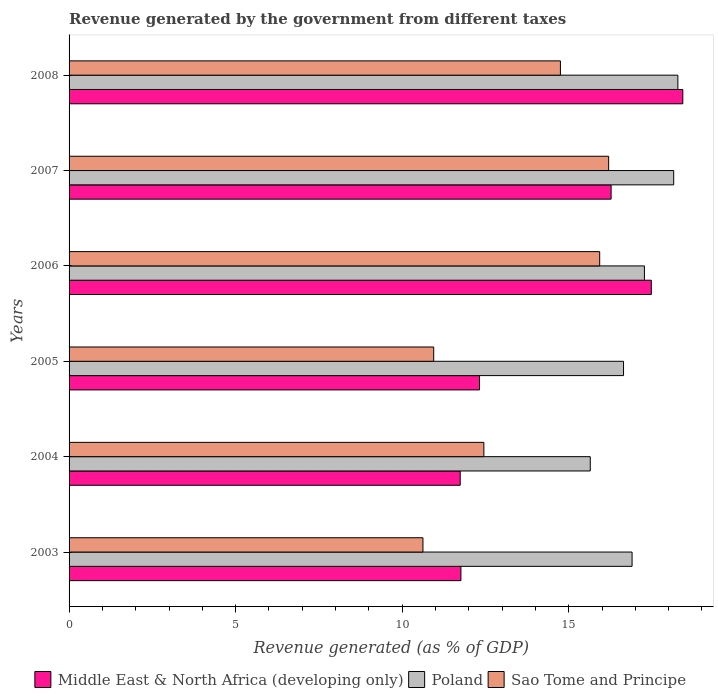How many different coloured bars are there?
Your answer should be compact. 3. How many bars are there on the 2nd tick from the bottom?
Your answer should be compact. 3. What is the revenue generated by the government in Middle East & North Africa (developing only) in 2007?
Offer a terse response. 16.27. Across all years, what is the maximum revenue generated by the government in Poland?
Provide a short and direct response. 18.28. Across all years, what is the minimum revenue generated by the government in Middle East & North Africa (developing only)?
Give a very brief answer. 11.74. In which year was the revenue generated by the government in Poland maximum?
Your response must be concise. 2008. What is the total revenue generated by the government in Sao Tome and Principe in the graph?
Give a very brief answer. 80.91. What is the difference between the revenue generated by the government in Poland in 2007 and that in 2008?
Provide a short and direct response. -0.13. What is the difference between the revenue generated by the government in Middle East & North Africa (developing only) in 2005 and the revenue generated by the government in Sao Tome and Principe in 2008?
Your response must be concise. -2.43. What is the average revenue generated by the government in Middle East & North Africa (developing only) per year?
Your answer should be compact. 14.67. In the year 2006, what is the difference between the revenue generated by the government in Sao Tome and Principe and revenue generated by the government in Poland?
Make the answer very short. -1.34. In how many years, is the revenue generated by the government in Sao Tome and Principe greater than 13 %?
Make the answer very short. 3. What is the ratio of the revenue generated by the government in Poland in 2005 to that in 2008?
Give a very brief answer. 0.91. Is the revenue generated by the government in Poland in 2003 less than that in 2008?
Keep it short and to the point. Yes. What is the difference between the highest and the second highest revenue generated by the government in Middle East & North Africa (developing only)?
Keep it short and to the point. 0.95. What is the difference between the highest and the lowest revenue generated by the government in Sao Tome and Principe?
Your response must be concise. 5.57. Is the sum of the revenue generated by the government in Poland in 2006 and 2007 greater than the maximum revenue generated by the government in Sao Tome and Principe across all years?
Ensure brevity in your answer.  Yes. What does the 1st bar from the top in 2005 represents?
Your answer should be very brief. Sao Tome and Principe. What does the 1st bar from the bottom in 2008 represents?
Provide a succinct answer. Middle East & North Africa (developing only). Is it the case that in every year, the sum of the revenue generated by the government in Sao Tome and Principe and revenue generated by the government in Poland is greater than the revenue generated by the government in Middle East & North Africa (developing only)?
Your answer should be very brief. Yes. How many bars are there?
Ensure brevity in your answer.  18. Are all the bars in the graph horizontal?
Your response must be concise. Yes. How many years are there in the graph?
Make the answer very short. 6. What is the difference between two consecutive major ticks on the X-axis?
Provide a short and direct response. 5. Are the values on the major ticks of X-axis written in scientific E-notation?
Keep it short and to the point. No. Does the graph contain grids?
Provide a succinct answer. No. How many legend labels are there?
Provide a succinct answer. 3. What is the title of the graph?
Give a very brief answer. Revenue generated by the government from different taxes. Does "Zimbabwe" appear as one of the legend labels in the graph?
Give a very brief answer. No. What is the label or title of the X-axis?
Make the answer very short. Revenue generated (as % of GDP). What is the Revenue generated (as % of GDP) in Middle East & North Africa (developing only) in 2003?
Make the answer very short. 11.76. What is the Revenue generated (as % of GDP) in Poland in 2003?
Keep it short and to the point. 16.9. What is the Revenue generated (as % of GDP) of Sao Tome and Principe in 2003?
Provide a short and direct response. 10.62. What is the Revenue generated (as % of GDP) in Middle East & North Africa (developing only) in 2004?
Offer a very short reply. 11.74. What is the Revenue generated (as % of GDP) in Poland in 2004?
Your answer should be very brief. 15.65. What is the Revenue generated (as % of GDP) in Sao Tome and Principe in 2004?
Your response must be concise. 12.45. What is the Revenue generated (as % of GDP) in Middle East & North Africa (developing only) in 2005?
Your answer should be compact. 12.32. What is the Revenue generated (as % of GDP) in Poland in 2005?
Provide a short and direct response. 16.65. What is the Revenue generated (as % of GDP) in Sao Tome and Principe in 2005?
Offer a terse response. 10.95. What is the Revenue generated (as % of GDP) in Middle East & North Africa (developing only) in 2006?
Make the answer very short. 17.48. What is the Revenue generated (as % of GDP) in Poland in 2006?
Provide a succinct answer. 17.27. What is the Revenue generated (as % of GDP) in Sao Tome and Principe in 2006?
Ensure brevity in your answer.  15.93. What is the Revenue generated (as % of GDP) of Middle East & North Africa (developing only) in 2007?
Your answer should be very brief. 16.27. What is the Revenue generated (as % of GDP) of Poland in 2007?
Offer a very short reply. 18.15. What is the Revenue generated (as % of GDP) in Sao Tome and Principe in 2007?
Make the answer very short. 16.2. What is the Revenue generated (as % of GDP) of Middle East & North Africa (developing only) in 2008?
Ensure brevity in your answer.  18.43. What is the Revenue generated (as % of GDP) of Poland in 2008?
Your answer should be very brief. 18.28. What is the Revenue generated (as % of GDP) in Sao Tome and Principe in 2008?
Give a very brief answer. 14.75. Across all years, what is the maximum Revenue generated (as % of GDP) of Middle East & North Africa (developing only)?
Give a very brief answer. 18.43. Across all years, what is the maximum Revenue generated (as % of GDP) in Poland?
Keep it short and to the point. 18.28. Across all years, what is the maximum Revenue generated (as % of GDP) of Sao Tome and Principe?
Give a very brief answer. 16.2. Across all years, what is the minimum Revenue generated (as % of GDP) of Middle East & North Africa (developing only)?
Provide a succinct answer. 11.74. Across all years, what is the minimum Revenue generated (as % of GDP) in Poland?
Make the answer very short. 15.65. Across all years, what is the minimum Revenue generated (as % of GDP) in Sao Tome and Principe?
Offer a very short reply. 10.62. What is the total Revenue generated (as % of GDP) of Middle East & North Africa (developing only) in the graph?
Provide a short and direct response. 88.01. What is the total Revenue generated (as % of GDP) in Poland in the graph?
Offer a very short reply. 102.9. What is the total Revenue generated (as % of GDP) of Sao Tome and Principe in the graph?
Give a very brief answer. 80.91. What is the difference between the Revenue generated (as % of GDP) in Middle East & North Africa (developing only) in 2003 and that in 2004?
Keep it short and to the point. 0.02. What is the difference between the Revenue generated (as % of GDP) in Poland in 2003 and that in 2004?
Your response must be concise. 1.26. What is the difference between the Revenue generated (as % of GDP) of Sao Tome and Principe in 2003 and that in 2004?
Ensure brevity in your answer.  -1.83. What is the difference between the Revenue generated (as % of GDP) in Middle East & North Africa (developing only) in 2003 and that in 2005?
Provide a succinct answer. -0.56. What is the difference between the Revenue generated (as % of GDP) in Poland in 2003 and that in 2005?
Your response must be concise. 0.26. What is the difference between the Revenue generated (as % of GDP) in Sao Tome and Principe in 2003 and that in 2005?
Offer a very short reply. -0.32. What is the difference between the Revenue generated (as % of GDP) in Middle East & North Africa (developing only) in 2003 and that in 2006?
Provide a succinct answer. -5.72. What is the difference between the Revenue generated (as % of GDP) in Poland in 2003 and that in 2006?
Give a very brief answer. -0.37. What is the difference between the Revenue generated (as % of GDP) in Sao Tome and Principe in 2003 and that in 2006?
Your answer should be very brief. -5.31. What is the difference between the Revenue generated (as % of GDP) of Middle East & North Africa (developing only) in 2003 and that in 2007?
Keep it short and to the point. -4.51. What is the difference between the Revenue generated (as % of GDP) in Poland in 2003 and that in 2007?
Offer a very short reply. -1.25. What is the difference between the Revenue generated (as % of GDP) of Sao Tome and Principe in 2003 and that in 2007?
Offer a very short reply. -5.57. What is the difference between the Revenue generated (as % of GDP) in Middle East & North Africa (developing only) in 2003 and that in 2008?
Provide a succinct answer. -6.66. What is the difference between the Revenue generated (as % of GDP) of Poland in 2003 and that in 2008?
Offer a terse response. -1.38. What is the difference between the Revenue generated (as % of GDP) in Sao Tome and Principe in 2003 and that in 2008?
Ensure brevity in your answer.  -4.13. What is the difference between the Revenue generated (as % of GDP) of Middle East & North Africa (developing only) in 2004 and that in 2005?
Provide a succinct answer. -0.58. What is the difference between the Revenue generated (as % of GDP) of Poland in 2004 and that in 2005?
Your response must be concise. -1. What is the difference between the Revenue generated (as % of GDP) in Sao Tome and Principe in 2004 and that in 2005?
Make the answer very short. 1.51. What is the difference between the Revenue generated (as % of GDP) in Middle East & North Africa (developing only) in 2004 and that in 2006?
Make the answer very short. -5.74. What is the difference between the Revenue generated (as % of GDP) of Poland in 2004 and that in 2006?
Provide a short and direct response. -1.63. What is the difference between the Revenue generated (as % of GDP) of Sao Tome and Principe in 2004 and that in 2006?
Provide a succinct answer. -3.48. What is the difference between the Revenue generated (as % of GDP) of Middle East & North Africa (developing only) in 2004 and that in 2007?
Give a very brief answer. -4.53. What is the difference between the Revenue generated (as % of GDP) in Poland in 2004 and that in 2007?
Your answer should be very brief. -2.51. What is the difference between the Revenue generated (as % of GDP) of Sao Tome and Principe in 2004 and that in 2007?
Your answer should be compact. -3.75. What is the difference between the Revenue generated (as % of GDP) in Middle East & North Africa (developing only) in 2004 and that in 2008?
Make the answer very short. -6.68. What is the difference between the Revenue generated (as % of GDP) of Poland in 2004 and that in 2008?
Your answer should be compact. -2.63. What is the difference between the Revenue generated (as % of GDP) of Sao Tome and Principe in 2004 and that in 2008?
Offer a very short reply. -2.3. What is the difference between the Revenue generated (as % of GDP) of Middle East & North Africa (developing only) in 2005 and that in 2006?
Make the answer very short. -5.16. What is the difference between the Revenue generated (as % of GDP) of Poland in 2005 and that in 2006?
Give a very brief answer. -0.63. What is the difference between the Revenue generated (as % of GDP) in Sao Tome and Principe in 2005 and that in 2006?
Offer a very short reply. -4.98. What is the difference between the Revenue generated (as % of GDP) in Middle East & North Africa (developing only) in 2005 and that in 2007?
Make the answer very short. -3.95. What is the difference between the Revenue generated (as % of GDP) of Poland in 2005 and that in 2007?
Provide a succinct answer. -1.51. What is the difference between the Revenue generated (as % of GDP) in Sao Tome and Principe in 2005 and that in 2007?
Keep it short and to the point. -5.25. What is the difference between the Revenue generated (as % of GDP) in Middle East & North Africa (developing only) in 2005 and that in 2008?
Provide a short and direct response. -6.1. What is the difference between the Revenue generated (as % of GDP) in Poland in 2005 and that in 2008?
Make the answer very short. -1.63. What is the difference between the Revenue generated (as % of GDP) in Sao Tome and Principe in 2005 and that in 2008?
Your response must be concise. -3.8. What is the difference between the Revenue generated (as % of GDP) in Middle East & North Africa (developing only) in 2006 and that in 2007?
Your response must be concise. 1.21. What is the difference between the Revenue generated (as % of GDP) of Poland in 2006 and that in 2007?
Provide a succinct answer. -0.88. What is the difference between the Revenue generated (as % of GDP) in Sao Tome and Principe in 2006 and that in 2007?
Offer a very short reply. -0.27. What is the difference between the Revenue generated (as % of GDP) of Middle East & North Africa (developing only) in 2006 and that in 2008?
Your response must be concise. -0.95. What is the difference between the Revenue generated (as % of GDP) in Poland in 2006 and that in 2008?
Ensure brevity in your answer.  -1. What is the difference between the Revenue generated (as % of GDP) in Sao Tome and Principe in 2006 and that in 2008?
Provide a succinct answer. 1.18. What is the difference between the Revenue generated (as % of GDP) in Middle East & North Africa (developing only) in 2007 and that in 2008?
Offer a terse response. -2.15. What is the difference between the Revenue generated (as % of GDP) of Poland in 2007 and that in 2008?
Offer a very short reply. -0.13. What is the difference between the Revenue generated (as % of GDP) of Sao Tome and Principe in 2007 and that in 2008?
Your answer should be compact. 1.45. What is the difference between the Revenue generated (as % of GDP) in Middle East & North Africa (developing only) in 2003 and the Revenue generated (as % of GDP) in Poland in 2004?
Your response must be concise. -3.88. What is the difference between the Revenue generated (as % of GDP) in Middle East & North Africa (developing only) in 2003 and the Revenue generated (as % of GDP) in Sao Tome and Principe in 2004?
Your response must be concise. -0.69. What is the difference between the Revenue generated (as % of GDP) of Poland in 2003 and the Revenue generated (as % of GDP) of Sao Tome and Principe in 2004?
Give a very brief answer. 4.45. What is the difference between the Revenue generated (as % of GDP) of Middle East & North Africa (developing only) in 2003 and the Revenue generated (as % of GDP) of Poland in 2005?
Provide a succinct answer. -4.88. What is the difference between the Revenue generated (as % of GDP) in Middle East & North Africa (developing only) in 2003 and the Revenue generated (as % of GDP) in Sao Tome and Principe in 2005?
Provide a succinct answer. 0.82. What is the difference between the Revenue generated (as % of GDP) in Poland in 2003 and the Revenue generated (as % of GDP) in Sao Tome and Principe in 2005?
Give a very brief answer. 5.96. What is the difference between the Revenue generated (as % of GDP) of Middle East & North Africa (developing only) in 2003 and the Revenue generated (as % of GDP) of Poland in 2006?
Provide a short and direct response. -5.51. What is the difference between the Revenue generated (as % of GDP) of Middle East & North Africa (developing only) in 2003 and the Revenue generated (as % of GDP) of Sao Tome and Principe in 2006?
Ensure brevity in your answer.  -4.17. What is the difference between the Revenue generated (as % of GDP) of Poland in 2003 and the Revenue generated (as % of GDP) of Sao Tome and Principe in 2006?
Provide a succinct answer. 0.97. What is the difference between the Revenue generated (as % of GDP) of Middle East & North Africa (developing only) in 2003 and the Revenue generated (as % of GDP) of Poland in 2007?
Your answer should be compact. -6.39. What is the difference between the Revenue generated (as % of GDP) in Middle East & North Africa (developing only) in 2003 and the Revenue generated (as % of GDP) in Sao Tome and Principe in 2007?
Your response must be concise. -4.43. What is the difference between the Revenue generated (as % of GDP) of Poland in 2003 and the Revenue generated (as % of GDP) of Sao Tome and Principe in 2007?
Provide a short and direct response. 0.7. What is the difference between the Revenue generated (as % of GDP) of Middle East & North Africa (developing only) in 2003 and the Revenue generated (as % of GDP) of Poland in 2008?
Your answer should be compact. -6.51. What is the difference between the Revenue generated (as % of GDP) of Middle East & North Africa (developing only) in 2003 and the Revenue generated (as % of GDP) of Sao Tome and Principe in 2008?
Provide a short and direct response. -2.99. What is the difference between the Revenue generated (as % of GDP) of Poland in 2003 and the Revenue generated (as % of GDP) of Sao Tome and Principe in 2008?
Offer a very short reply. 2.15. What is the difference between the Revenue generated (as % of GDP) in Middle East & North Africa (developing only) in 2004 and the Revenue generated (as % of GDP) in Poland in 2005?
Offer a very short reply. -4.9. What is the difference between the Revenue generated (as % of GDP) of Middle East & North Africa (developing only) in 2004 and the Revenue generated (as % of GDP) of Sao Tome and Principe in 2005?
Your answer should be very brief. 0.8. What is the difference between the Revenue generated (as % of GDP) in Poland in 2004 and the Revenue generated (as % of GDP) in Sao Tome and Principe in 2005?
Keep it short and to the point. 4.7. What is the difference between the Revenue generated (as % of GDP) of Middle East & North Africa (developing only) in 2004 and the Revenue generated (as % of GDP) of Poland in 2006?
Make the answer very short. -5.53. What is the difference between the Revenue generated (as % of GDP) in Middle East & North Africa (developing only) in 2004 and the Revenue generated (as % of GDP) in Sao Tome and Principe in 2006?
Your answer should be compact. -4.19. What is the difference between the Revenue generated (as % of GDP) of Poland in 2004 and the Revenue generated (as % of GDP) of Sao Tome and Principe in 2006?
Your answer should be compact. -0.28. What is the difference between the Revenue generated (as % of GDP) in Middle East & North Africa (developing only) in 2004 and the Revenue generated (as % of GDP) in Poland in 2007?
Your response must be concise. -6.41. What is the difference between the Revenue generated (as % of GDP) of Middle East & North Africa (developing only) in 2004 and the Revenue generated (as % of GDP) of Sao Tome and Principe in 2007?
Ensure brevity in your answer.  -4.46. What is the difference between the Revenue generated (as % of GDP) of Poland in 2004 and the Revenue generated (as % of GDP) of Sao Tome and Principe in 2007?
Give a very brief answer. -0.55. What is the difference between the Revenue generated (as % of GDP) in Middle East & North Africa (developing only) in 2004 and the Revenue generated (as % of GDP) in Poland in 2008?
Give a very brief answer. -6.54. What is the difference between the Revenue generated (as % of GDP) of Middle East & North Africa (developing only) in 2004 and the Revenue generated (as % of GDP) of Sao Tome and Principe in 2008?
Your answer should be compact. -3.01. What is the difference between the Revenue generated (as % of GDP) of Poland in 2004 and the Revenue generated (as % of GDP) of Sao Tome and Principe in 2008?
Make the answer very short. 0.9. What is the difference between the Revenue generated (as % of GDP) of Middle East & North Africa (developing only) in 2005 and the Revenue generated (as % of GDP) of Poland in 2006?
Provide a succinct answer. -4.95. What is the difference between the Revenue generated (as % of GDP) of Middle East & North Africa (developing only) in 2005 and the Revenue generated (as % of GDP) of Sao Tome and Principe in 2006?
Make the answer very short. -3.61. What is the difference between the Revenue generated (as % of GDP) of Poland in 2005 and the Revenue generated (as % of GDP) of Sao Tome and Principe in 2006?
Offer a very short reply. 0.72. What is the difference between the Revenue generated (as % of GDP) in Middle East & North Africa (developing only) in 2005 and the Revenue generated (as % of GDP) in Poland in 2007?
Give a very brief answer. -5.83. What is the difference between the Revenue generated (as % of GDP) of Middle East & North Africa (developing only) in 2005 and the Revenue generated (as % of GDP) of Sao Tome and Principe in 2007?
Offer a terse response. -3.88. What is the difference between the Revenue generated (as % of GDP) in Poland in 2005 and the Revenue generated (as % of GDP) in Sao Tome and Principe in 2007?
Ensure brevity in your answer.  0.45. What is the difference between the Revenue generated (as % of GDP) in Middle East & North Africa (developing only) in 2005 and the Revenue generated (as % of GDP) in Poland in 2008?
Offer a terse response. -5.96. What is the difference between the Revenue generated (as % of GDP) in Middle East & North Africa (developing only) in 2005 and the Revenue generated (as % of GDP) in Sao Tome and Principe in 2008?
Keep it short and to the point. -2.43. What is the difference between the Revenue generated (as % of GDP) of Poland in 2005 and the Revenue generated (as % of GDP) of Sao Tome and Principe in 2008?
Offer a very short reply. 1.89. What is the difference between the Revenue generated (as % of GDP) in Middle East & North Africa (developing only) in 2006 and the Revenue generated (as % of GDP) in Poland in 2007?
Offer a terse response. -0.67. What is the difference between the Revenue generated (as % of GDP) of Middle East & North Africa (developing only) in 2006 and the Revenue generated (as % of GDP) of Sao Tome and Principe in 2007?
Provide a succinct answer. 1.28. What is the difference between the Revenue generated (as % of GDP) of Poland in 2006 and the Revenue generated (as % of GDP) of Sao Tome and Principe in 2007?
Give a very brief answer. 1.07. What is the difference between the Revenue generated (as % of GDP) of Middle East & North Africa (developing only) in 2006 and the Revenue generated (as % of GDP) of Poland in 2008?
Keep it short and to the point. -0.8. What is the difference between the Revenue generated (as % of GDP) of Middle East & North Africa (developing only) in 2006 and the Revenue generated (as % of GDP) of Sao Tome and Principe in 2008?
Make the answer very short. 2.73. What is the difference between the Revenue generated (as % of GDP) of Poland in 2006 and the Revenue generated (as % of GDP) of Sao Tome and Principe in 2008?
Offer a terse response. 2.52. What is the difference between the Revenue generated (as % of GDP) of Middle East & North Africa (developing only) in 2007 and the Revenue generated (as % of GDP) of Poland in 2008?
Make the answer very short. -2. What is the difference between the Revenue generated (as % of GDP) of Middle East & North Africa (developing only) in 2007 and the Revenue generated (as % of GDP) of Sao Tome and Principe in 2008?
Your answer should be very brief. 1.52. What is the difference between the Revenue generated (as % of GDP) of Poland in 2007 and the Revenue generated (as % of GDP) of Sao Tome and Principe in 2008?
Your answer should be compact. 3.4. What is the average Revenue generated (as % of GDP) of Middle East & North Africa (developing only) per year?
Provide a short and direct response. 14.67. What is the average Revenue generated (as % of GDP) of Poland per year?
Keep it short and to the point. 17.15. What is the average Revenue generated (as % of GDP) in Sao Tome and Principe per year?
Your response must be concise. 13.48. In the year 2003, what is the difference between the Revenue generated (as % of GDP) in Middle East & North Africa (developing only) and Revenue generated (as % of GDP) in Poland?
Make the answer very short. -5.14. In the year 2003, what is the difference between the Revenue generated (as % of GDP) of Middle East & North Africa (developing only) and Revenue generated (as % of GDP) of Sao Tome and Principe?
Provide a succinct answer. 1.14. In the year 2003, what is the difference between the Revenue generated (as % of GDP) in Poland and Revenue generated (as % of GDP) in Sao Tome and Principe?
Give a very brief answer. 6.28. In the year 2004, what is the difference between the Revenue generated (as % of GDP) in Middle East & North Africa (developing only) and Revenue generated (as % of GDP) in Poland?
Provide a short and direct response. -3.9. In the year 2004, what is the difference between the Revenue generated (as % of GDP) in Middle East & North Africa (developing only) and Revenue generated (as % of GDP) in Sao Tome and Principe?
Your response must be concise. -0.71. In the year 2004, what is the difference between the Revenue generated (as % of GDP) in Poland and Revenue generated (as % of GDP) in Sao Tome and Principe?
Offer a terse response. 3.19. In the year 2005, what is the difference between the Revenue generated (as % of GDP) in Middle East & North Africa (developing only) and Revenue generated (as % of GDP) in Poland?
Your response must be concise. -4.32. In the year 2005, what is the difference between the Revenue generated (as % of GDP) of Middle East & North Africa (developing only) and Revenue generated (as % of GDP) of Sao Tome and Principe?
Make the answer very short. 1.38. In the year 2005, what is the difference between the Revenue generated (as % of GDP) of Poland and Revenue generated (as % of GDP) of Sao Tome and Principe?
Offer a terse response. 5.7. In the year 2006, what is the difference between the Revenue generated (as % of GDP) of Middle East & North Africa (developing only) and Revenue generated (as % of GDP) of Poland?
Your answer should be very brief. 0.21. In the year 2006, what is the difference between the Revenue generated (as % of GDP) in Middle East & North Africa (developing only) and Revenue generated (as % of GDP) in Sao Tome and Principe?
Provide a succinct answer. 1.55. In the year 2006, what is the difference between the Revenue generated (as % of GDP) of Poland and Revenue generated (as % of GDP) of Sao Tome and Principe?
Make the answer very short. 1.34. In the year 2007, what is the difference between the Revenue generated (as % of GDP) in Middle East & North Africa (developing only) and Revenue generated (as % of GDP) in Poland?
Provide a short and direct response. -1.88. In the year 2007, what is the difference between the Revenue generated (as % of GDP) in Middle East & North Africa (developing only) and Revenue generated (as % of GDP) in Sao Tome and Principe?
Offer a terse response. 0.07. In the year 2007, what is the difference between the Revenue generated (as % of GDP) in Poland and Revenue generated (as % of GDP) in Sao Tome and Principe?
Offer a very short reply. 1.95. In the year 2008, what is the difference between the Revenue generated (as % of GDP) of Middle East & North Africa (developing only) and Revenue generated (as % of GDP) of Poland?
Make the answer very short. 0.15. In the year 2008, what is the difference between the Revenue generated (as % of GDP) of Middle East & North Africa (developing only) and Revenue generated (as % of GDP) of Sao Tome and Principe?
Provide a succinct answer. 3.67. In the year 2008, what is the difference between the Revenue generated (as % of GDP) in Poland and Revenue generated (as % of GDP) in Sao Tome and Principe?
Provide a succinct answer. 3.53. What is the ratio of the Revenue generated (as % of GDP) in Middle East & North Africa (developing only) in 2003 to that in 2004?
Keep it short and to the point. 1. What is the ratio of the Revenue generated (as % of GDP) in Poland in 2003 to that in 2004?
Your response must be concise. 1.08. What is the ratio of the Revenue generated (as % of GDP) in Sao Tome and Principe in 2003 to that in 2004?
Keep it short and to the point. 0.85. What is the ratio of the Revenue generated (as % of GDP) in Middle East & North Africa (developing only) in 2003 to that in 2005?
Give a very brief answer. 0.95. What is the ratio of the Revenue generated (as % of GDP) in Poland in 2003 to that in 2005?
Offer a terse response. 1.02. What is the ratio of the Revenue generated (as % of GDP) in Sao Tome and Principe in 2003 to that in 2005?
Your answer should be very brief. 0.97. What is the ratio of the Revenue generated (as % of GDP) in Middle East & North Africa (developing only) in 2003 to that in 2006?
Ensure brevity in your answer.  0.67. What is the ratio of the Revenue generated (as % of GDP) of Poland in 2003 to that in 2006?
Provide a short and direct response. 0.98. What is the ratio of the Revenue generated (as % of GDP) in Sao Tome and Principe in 2003 to that in 2006?
Your response must be concise. 0.67. What is the ratio of the Revenue generated (as % of GDP) of Middle East & North Africa (developing only) in 2003 to that in 2007?
Your answer should be compact. 0.72. What is the ratio of the Revenue generated (as % of GDP) in Poland in 2003 to that in 2007?
Keep it short and to the point. 0.93. What is the ratio of the Revenue generated (as % of GDP) of Sao Tome and Principe in 2003 to that in 2007?
Offer a terse response. 0.66. What is the ratio of the Revenue generated (as % of GDP) in Middle East & North Africa (developing only) in 2003 to that in 2008?
Make the answer very short. 0.64. What is the ratio of the Revenue generated (as % of GDP) of Poland in 2003 to that in 2008?
Provide a short and direct response. 0.92. What is the ratio of the Revenue generated (as % of GDP) of Sao Tome and Principe in 2003 to that in 2008?
Offer a very short reply. 0.72. What is the ratio of the Revenue generated (as % of GDP) in Middle East & North Africa (developing only) in 2004 to that in 2005?
Your response must be concise. 0.95. What is the ratio of the Revenue generated (as % of GDP) of Sao Tome and Principe in 2004 to that in 2005?
Provide a short and direct response. 1.14. What is the ratio of the Revenue generated (as % of GDP) of Middle East & North Africa (developing only) in 2004 to that in 2006?
Provide a succinct answer. 0.67. What is the ratio of the Revenue generated (as % of GDP) of Poland in 2004 to that in 2006?
Give a very brief answer. 0.91. What is the ratio of the Revenue generated (as % of GDP) in Sao Tome and Principe in 2004 to that in 2006?
Your answer should be very brief. 0.78. What is the ratio of the Revenue generated (as % of GDP) in Middle East & North Africa (developing only) in 2004 to that in 2007?
Provide a short and direct response. 0.72. What is the ratio of the Revenue generated (as % of GDP) in Poland in 2004 to that in 2007?
Offer a very short reply. 0.86. What is the ratio of the Revenue generated (as % of GDP) in Sao Tome and Principe in 2004 to that in 2007?
Provide a succinct answer. 0.77. What is the ratio of the Revenue generated (as % of GDP) in Middle East & North Africa (developing only) in 2004 to that in 2008?
Make the answer very short. 0.64. What is the ratio of the Revenue generated (as % of GDP) in Poland in 2004 to that in 2008?
Make the answer very short. 0.86. What is the ratio of the Revenue generated (as % of GDP) of Sao Tome and Principe in 2004 to that in 2008?
Give a very brief answer. 0.84. What is the ratio of the Revenue generated (as % of GDP) in Middle East & North Africa (developing only) in 2005 to that in 2006?
Offer a very short reply. 0.7. What is the ratio of the Revenue generated (as % of GDP) of Poland in 2005 to that in 2006?
Offer a very short reply. 0.96. What is the ratio of the Revenue generated (as % of GDP) in Sao Tome and Principe in 2005 to that in 2006?
Offer a very short reply. 0.69. What is the ratio of the Revenue generated (as % of GDP) in Middle East & North Africa (developing only) in 2005 to that in 2007?
Provide a succinct answer. 0.76. What is the ratio of the Revenue generated (as % of GDP) of Poland in 2005 to that in 2007?
Provide a short and direct response. 0.92. What is the ratio of the Revenue generated (as % of GDP) in Sao Tome and Principe in 2005 to that in 2007?
Keep it short and to the point. 0.68. What is the ratio of the Revenue generated (as % of GDP) of Middle East & North Africa (developing only) in 2005 to that in 2008?
Offer a very short reply. 0.67. What is the ratio of the Revenue generated (as % of GDP) of Poland in 2005 to that in 2008?
Your response must be concise. 0.91. What is the ratio of the Revenue generated (as % of GDP) of Sao Tome and Principe in 2005 to that in 2008?
Offer a very short reply. 0.74. What is the ratio of the Revenue generated (as % of GDP) of Middle East & North Africa (developing only) in 2006 to that in 2007?
Your answer should be compact. 1.07. What is the ratio of the Revenue generated (as % of GDP) of Poland in 2006 to that in 2007?
Your answer should be very brief. 0.95. What is the ratio of the Revenue generated (as % of GDP) of Sao Tome and Principe in 2006 to that in 2007?
Your response must be concise. 0.98. What is the ratio of the Revenue generated (as % of GDP) in Middle East & North Africa (developing only) in 2006 to that in 2008?
Give a very brief answer. 0.95. What is the ratio of the Revenue generated (as % of GDP) in Poland in 2006 to that in 2008?
Your answer should be very brief. 0.95. What is the ratio of the Revenue generated (as % of GDP) in Sao Tome and Principe in 2006 to that in 2008?
Provide a short and direct response. 1.08. What is the ratio of the Revenue generated (as % of GDP) of Middle East & North Africa (developing only) in 2007 to that in 2008?
Offer a terse response. 0.88. What is the ratio of the Revenue generated (as % of GDP) of Sao Tome and Principe in 2007 to that in 2008?
Your answer should be compact. 1.1. What is the difference between the highest and the second highest Revenue generated (as % of GDP) of Middle East & North Africa (developing only)?
Provide a succinct answer. 0.95. What is the difference between the highest and the second highest Revenue generated (as % of GDP) of Poland?
Make the answer very short. 0.13. What is the difference between the highest and the second highest Revenue generated (as % of GDP) of Sao Tome and Principe?
Ensure brevity in your answer.  0.27. What is the difference between the highest and the lowest Revenue generated (as % of GDP) of Middle East & North Africa (developing only)?
Offer a very short reply. 6.68. What is the difference between the highest and the lowest Revenue generated (as % of GDP) in Poland?
Your answer should be very brief. 2.63. What is the difference between the highest and the lowest Revenue generated (as % of GDP) of Sao Tome and Principe?
Give a very brief answer. 5.57. 